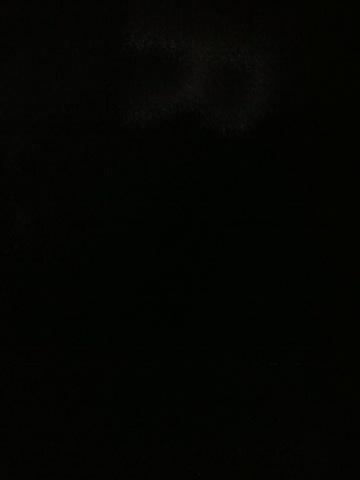Could this darkness be indicative of a low-light setting or a specific type of photograph? It's possible that the image was taken in a low-light setting, or it could be an artistic choice to create a specific mood or atmosphere. Low-light photography often requires a longer exposure time or a better camera sensor to capture more details. 